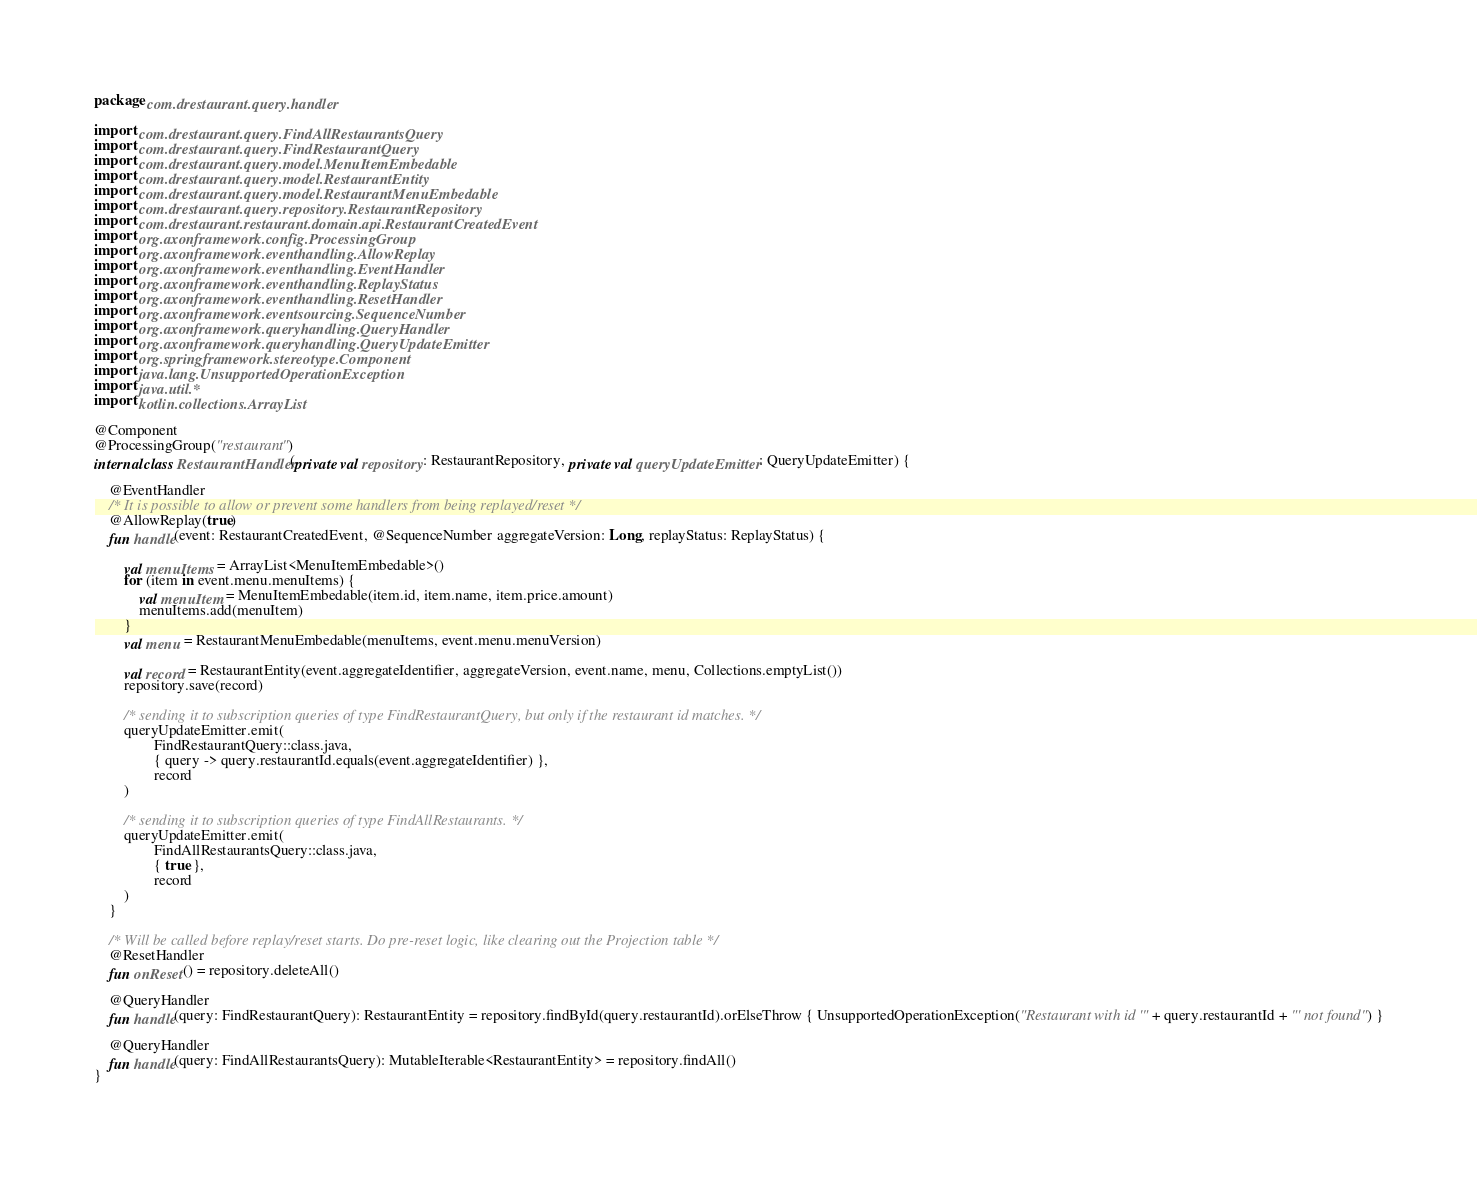Convert code to text. <code><loc_0><loc_0><loc_500><loc_500><_Kotlin_>package com.drestaurant.query.handler

import com.drestaurant.query.FindAllRestaurantsQuery
import com.drestaurant.query.FindRestaurantQuery
import com.drestaurant.query.model.MenuItemEmbedable
import com.drestaurant.query.model.RestaurantEntity
import com.drestaurant.query.model.RestaurantMenuEmbedable
import com.drestaurant.query.repository.RestaurantRepository
import com.drestaurant.restaurant.domain.api.RestaurantCreatedEvent
import org.axonframework.config.ProcessingGroup
import org.axonframework.eventhandling.AllowReplay
import org.axonframework.eventhandling.EventHandler
import org.axonframework.eventhandling.ReplayStatus
import org.axonframework.eventhandling.ResetHandler
import org.axonframework.eventsourcing.SequenceNumber
import org.axonframework.queryhandling.QueryHandler
import org.axonframework.queryhandling.QueryUpdateEmitter
import org.springframework.stereotype.Component
import java.lang.UnsupportedOperationException
import java.util.*
import kotlin.collections.ArrayList

@Component
@ProcessingGroup("restaurant")
internal class RestaurantHandler(private val repository: RestaurantRepository, private val queryUpdateEmitter: QueryUpdateEmitter) {

    @EventHandler
    /* It is possible to allow or prevent some handlers from being replayed/reset */
    @AllowReplay(true)
    fun handle(event: RestaurantCreatedEvent, @SequenceNumber aggregateVersion: Long, replayStatus: ReplayStatus) {

        val menuItems = ArrayList<MenuItemEmbedable>()
        for (item in event.menu.menuItems) {
            val menuItem = MenuItemEmbedable(item.id, item.name, item.price.amount)
            menuItems.add(menuItem)
        }
        val menu = RestaurantMenuEmbedable(menuItems, event.menu.menuVersion)

        val record = RestaurantEntity(event.aggregateIdentifier, aggregateVersion, event.name, menu, Collections.emptyList())
        repository.save(record)

        /* sending it to subscription queries of type FindRestaurantQuery, but only if the restaurant id matches. */
        queryUpdateEmitter.emit(
                FindRestaurantQuery::class.java,
                { query -> query.restaurantId.equals(event.aggregateIdentifier) },
                record
        )

        /* sending it to subscription queries of type FindAllRestaurants. */
        queryUpdateEmitter.emit(
                FindAllRestaurantsQuery::class.java,
                { true },
                record
        )
    }

    /* Will be called before replay/reset starts. Do pre-reset logic, like clearing out the Projection table */
    @ResetHandler
    fun onReset() = repository.deleteAll()

    @QueryHandler
    fun handle(query: FindRestaurantQuery): RestaurantEntity = repository.findById(query.restaurantId).orElseThrow { UnsupportedOperationException("Restaurant with id '" + query.restaurantId + "' not found") }

    @QueryHandler
    fun handle(query: FindAllRestaurantsQuery): MutableIterable<RestaurantEntity> = repository.findAll()
}
</code> 